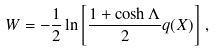Convert formula to latex. <formula><loc_0><loc_0><loc_500><loc_500>W = - \frac { 1 } { 2 } \ln \left [ \frac { 1 + \cosh \Lambda } { 2 } q ( X ) \right ] \, ,</formula> 